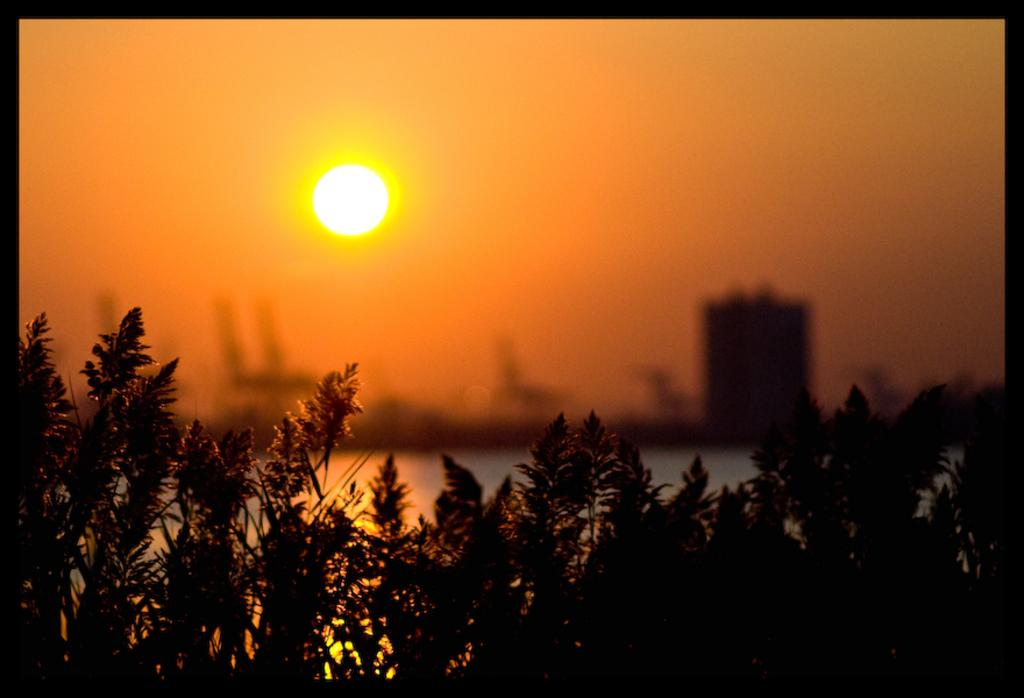What type of living organisms can be seen in the image? Plants can be seen in the image. What is the primary element visible in the image? Water is visible in the image. What can be seen in the background of the image? There is a building and the sky visible in the background of the image. Can the sun be seen in the image? Yes, the sun is observable in the sky. What type of cord is being used to play the drum in the image? There is no drum or cord present in the image. 